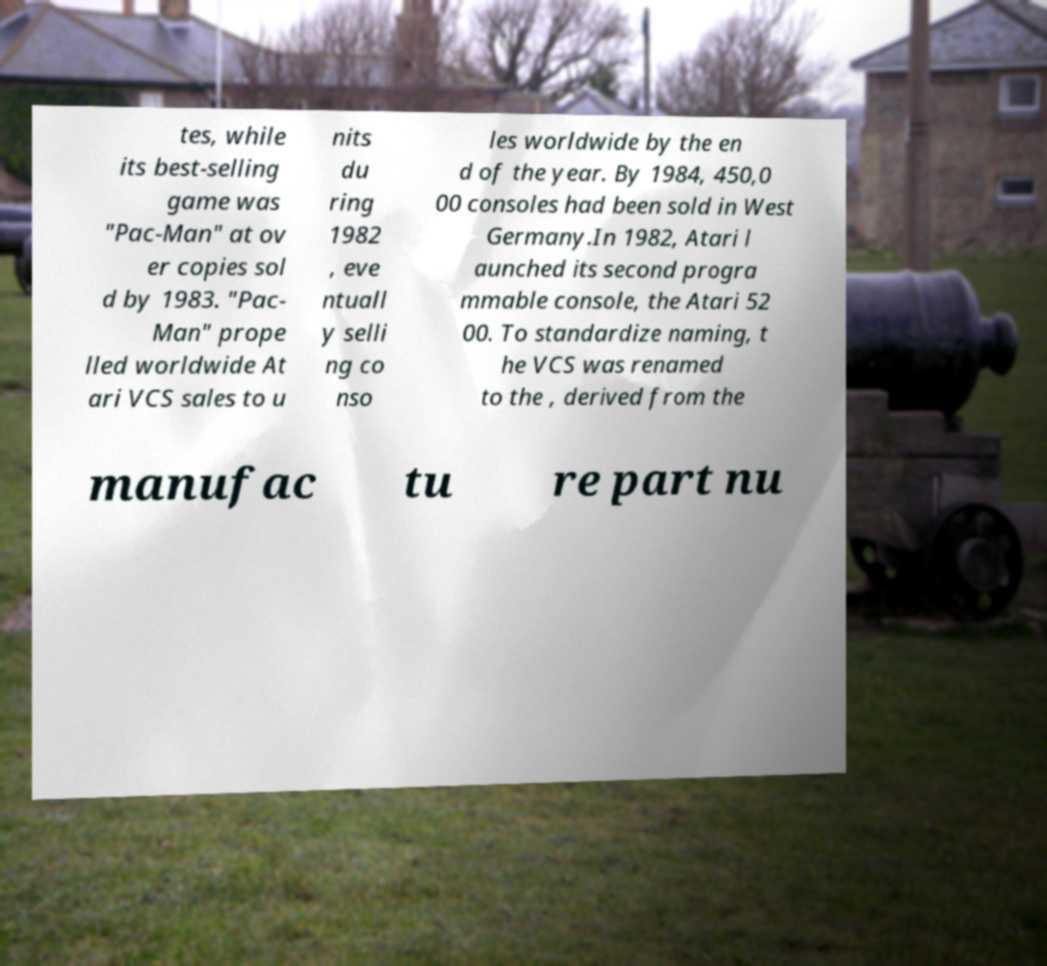What messages or text are displayed in this image? I need them in a readable, typed format. tes, while its best-selling game was "Pac-Man" at ov er copies sol d by 1983. "Pac- Man" prope lled worldwide At ari VCS sales to u nits du ring 1982 , eve ntuall y selli ng co nso les worldwide by the en d of the year. By 1984, 450,0 00 consoles had been sold in West Germany.In 1982, Atari l aunched its second progra mmable console, the Atari 52 00. To standardize naming, t he VCS was renamed to the , derived from the manufac tu re part nu 